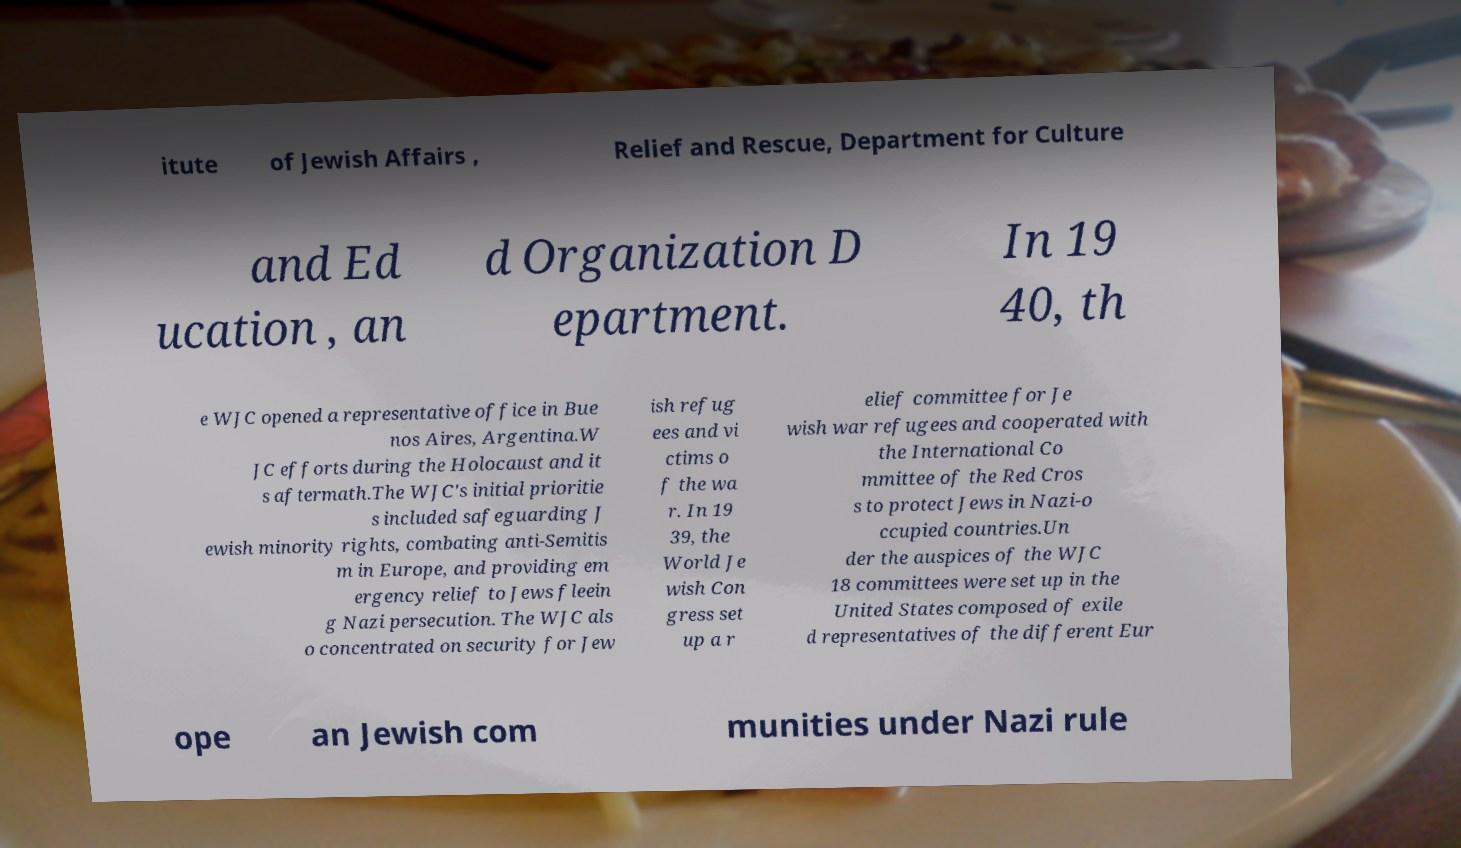There's text embedded in this image that I need extracted. Can you transcribe it verbatim? itute of Jewish Affairs , Relief and Rescue, Department for Culture and Ed ucation , an d Organization D epartment. In 19 40, th e WJC opened a representative office in Bue nos Aires, Argentina.W JC efforts during the Holocaust and it s aftermath.The WJC's initial prioritie s included safeguarding J ewish minority rights, combating anti-Semitis m in Europe, and providing em ergency relief to Jews fleein g Nazi persecution. The WJC als o concentrated on security for Jew ish refug ees and vi ctims o f the wa r. In 19 39, the World Je wish Con gress set up a r elief committee for Je wish war refugees and cooperated with the International Co mmittee of the Red Cros s to protect Jews in Nazi-o ccupied countries.Un der the auspices of the WJC 18 committees were set up in the United States composed of exile d representatives of the different Eur ope an Jewish com munities under Nazi rule 